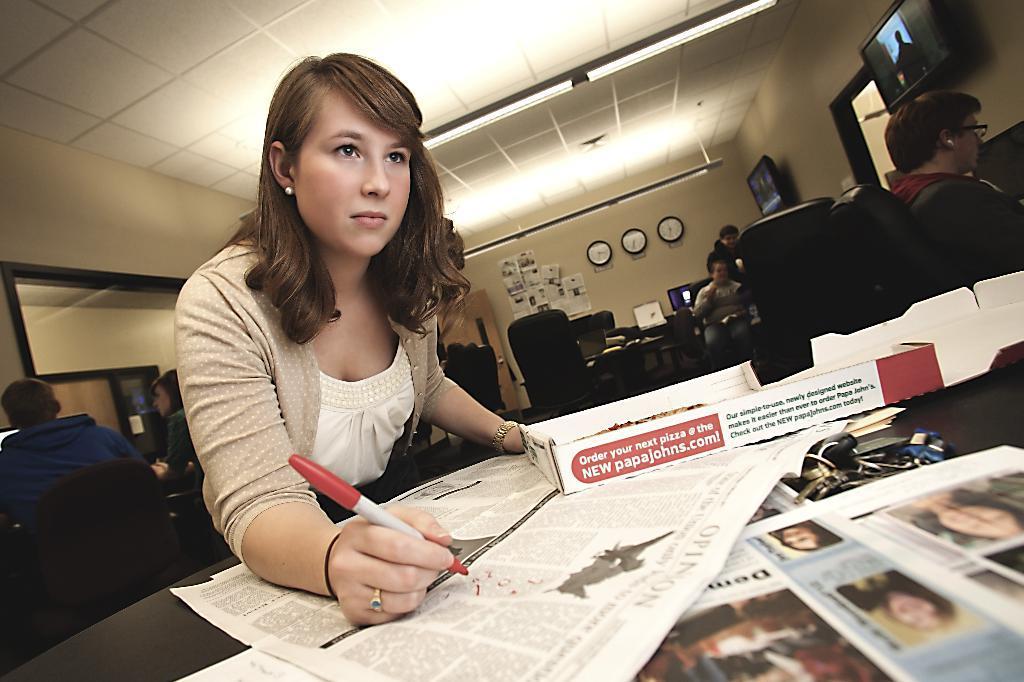Could you give a brief overview of what you see in this image? In this picture there is a woman holding a marker in her hand and writing something on a paper in front of her which is placed on the table and there are some other objects placed on it and there are few other persons sitting in chairs behind her and there are two televisions,few blocks attached to the wall in the background. 